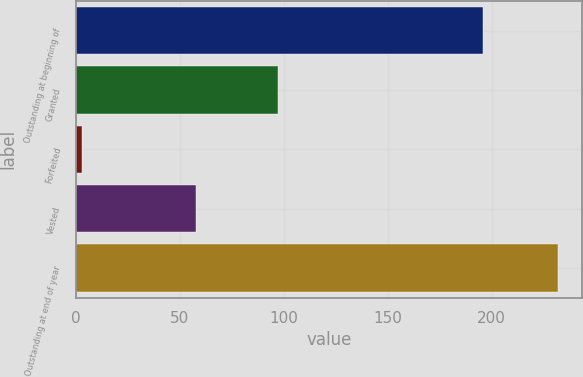Convert chart. <chart><loc_0><loc_0><loc_500><loc_500><bar_chart><fcel>Outstanding at beginning of<fcel>Granted<fcel>Forfeited<fcel>Vested<fcel>Outstanding at end of year<nl><fcel>196<fcel>97<fcel>3<fcel>58<fcel>232<nl></chart> 